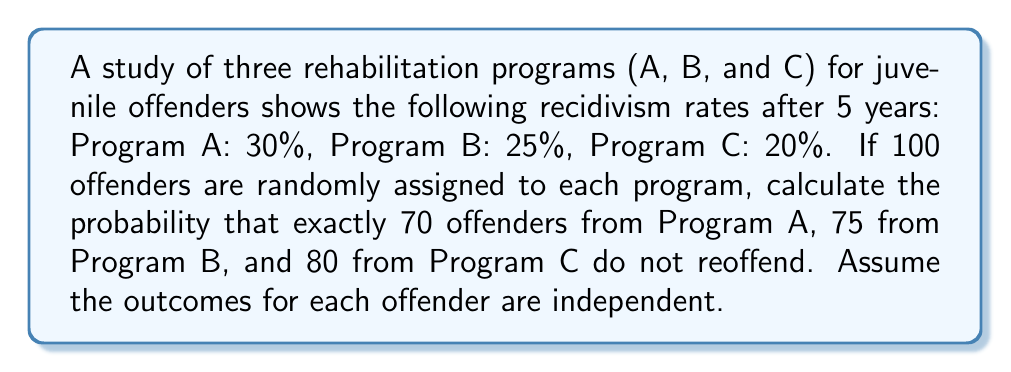Solve this math problem. To solve this problem, we'll use the binomial probability distribution for each program and then multiply the probabilities together.

1. For each program, we use the binomial probability formula:
   $$P(X=k) = \binom{n}{k} p^k (1-p)^{n-k}$$
   where $n$ is the number of trials, $k$ is the number of successes, and $p$ is the probability of success.

2. For Program A:
   $n = 100$, $k = 70$, $p = 0.7$ (probability of not reoffending)
   $$P_A = \binom{100}{70} 0.7^{70} 0.3^{30}$$

3. For Program B:
   $n = 100$, $k = 75$, $p = 0.75$
   $$P_B = \binom{100}{75} 0.75^{75} 0.25^{25}$$

4. For Program C:
   $n = 100$, $k = 80$, $p = 0.8$
   $$P_C = \binom{100}{80} 0.8^{80} 0.2^{20}$$

5. The probability of all these events occurring simultaneously is the product of their individual probabilities:
   $$P_{total} = P_A \times P_B \times P_C$$

6. Calculating the values (using a calculator or computer):
   $$P_A \approx 0.0418$$
   $$P_B \approx 0.0584$$
   $$P_C \approx 0.0561$$

7. The final probability:
   $$P_{total} \approx 0.0418 \times 0.0584 \times 0.0561 \approx 1.37 \times 10^{-4}$$
Answer: $1.37 \times 10^{-4}$ 